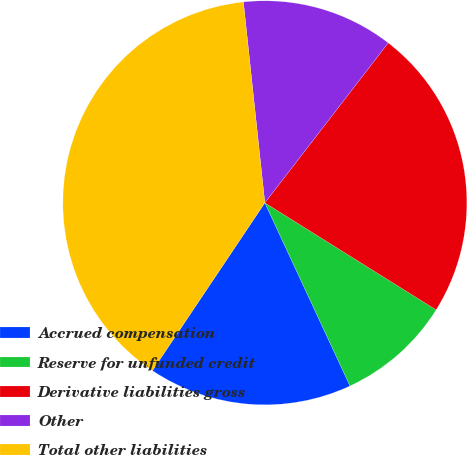<chart> <loc_0><loc_0><loc_500><loc_500><pie_chart><fcel>Accrued compensation<fcel>Reserve for unfunded credit<fcel>Derivative liabilities gross<fcel>Other<fcel>Total other liabilities<nl><fcel>16.32%<fcel>9.18%<fcel>23.43%<fcel>12.15%<fcel>38.91%<nl></chart> 